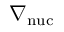Convert formula to latex. <formula><loc_0><loc_0><loc_500><loc_500>\nabla _ { n u c }</formula> 